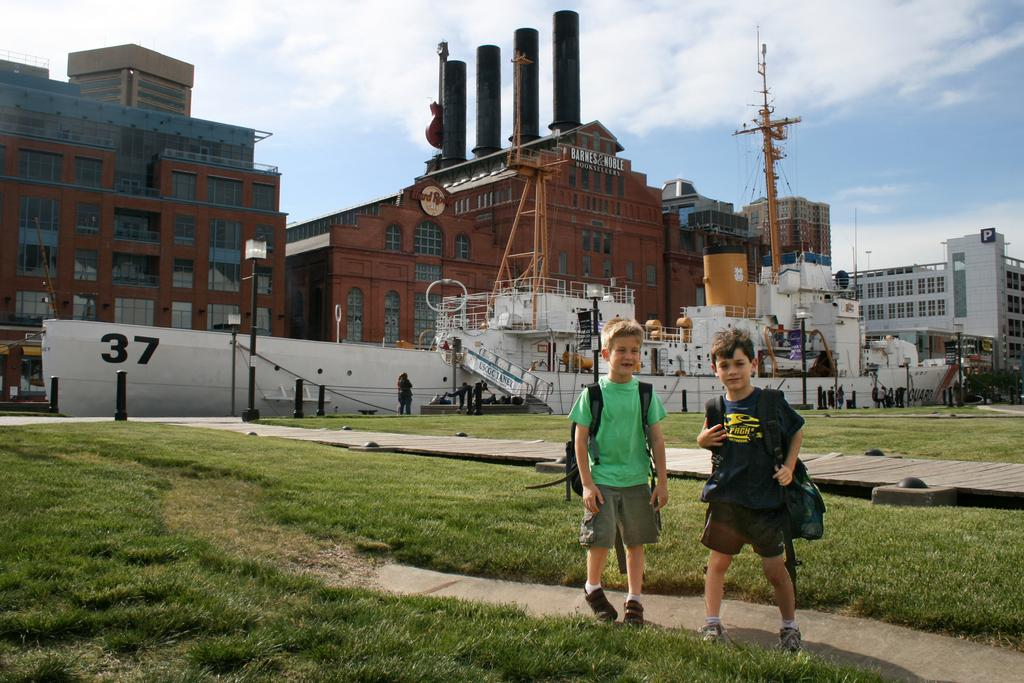What type of structures can be seen in the image? There are buildings in the image. What else is present in the image besides buildings? There are ships in the image. What are the kids at the bottom of the image doing? The kids are standing and wearing bags. What is visible at the top of the image? There is a sky at the top of the image. What type of gate is present in the image? There is no gate present in the image. How do the kids pull the ships in the image? The kids are not pulling any ships in the image; they are simply standing and wearing bags. 